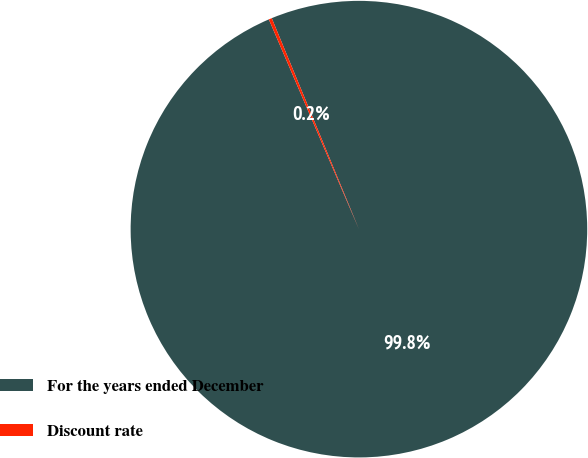<chart> <loc_0><loc_0><loc_500><loc_500><pie_chart><fcel>For the years ended December<fcel>Discount rate<nl><fcel>99.78%<fcel>0.22%<nl></chart> 